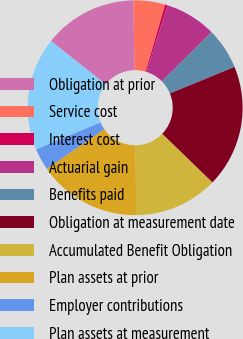Convert chart. <chart><loc_0><loc_0><loc_500><loc_500><pie_chart><fcel>Obligation at prior<fcel>Service cost<fcel>Interest cost<fcel>Actuarial gain<fcel>Benefits paid<fcel>Obligation at measurement date<fcel>Accumulated Benefit Obligation<fcel>Plan assets at prior<fcel>Employer contributions<fcel>Plan assets at measurement<nl><fcel>14.07%<fcel>4.77%<fcel>0.38%<fcel>7.69%<fcel>6.23%<fcel>18.45%<fcel>12.61%<fcel>15.53%<fcel>3.3%<fcel>16.99%<nl></chart> 